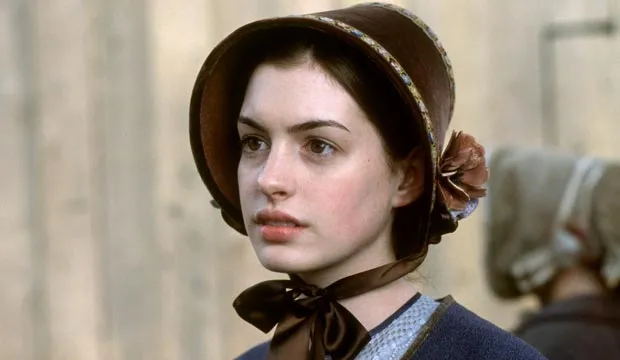Let's get creative! Could there be a magical or supernatural element in this scenario? Eleanor's bonnet wasn't just any piece of clothing—it was an enchanted heirloom passed down through generations. As she stood near the market, the ribbon around her neck began to glow softly, a sign that mystical forces were at play. She could sense the protective aura emanating from the bonnet, shielding her from unseen dangers. The blurred figure in the background was not an ordinary villager but a guardian spirit watching over her, ready to intervene should the magical forces threaten to overwhelm her. In this world, where magic and mundane moments intertwined, Eleanor's every step would shape the fate of not just her family but the very fabric of reality. If this image were part of a fantasy novel, what roles would the main and background characters play? In a fantasy novel, Eleanor could be the reluctant hero whose lineage holds a dormant magical legacy. The background figure, her guardian spirit, might be tasked with awakening her powers and guiding her through a world teetering on the edge of magical conflict. Eleanor's journey would involve discovering ancient prophecies, battling dark forces, and forging alliances with mystical beings, all while navigating the responsibilities and sacrifices required of her new role. Now imagine she holds a mysterious artifact—what could it be and what powers does it have? In her hands, Eleanor clutches an ancient, intricately carved amulet embedded with a glowing sapphire. This artifact, known as the Amulet of Aether, has the power to manipulate time and space. With it, Eleanor can glimpse into the past, foresee future events, and even create temporal distortions to navigate through obstacles. However, its use comes with a heavy price, draining her energy and attracting the attention of dark entities that covet its power. The amulet’s true purpose, shrouded in mystery, is said to seal or unleash the ancient forces that once governed the world, depending on the purity of the wielder’s heart. 